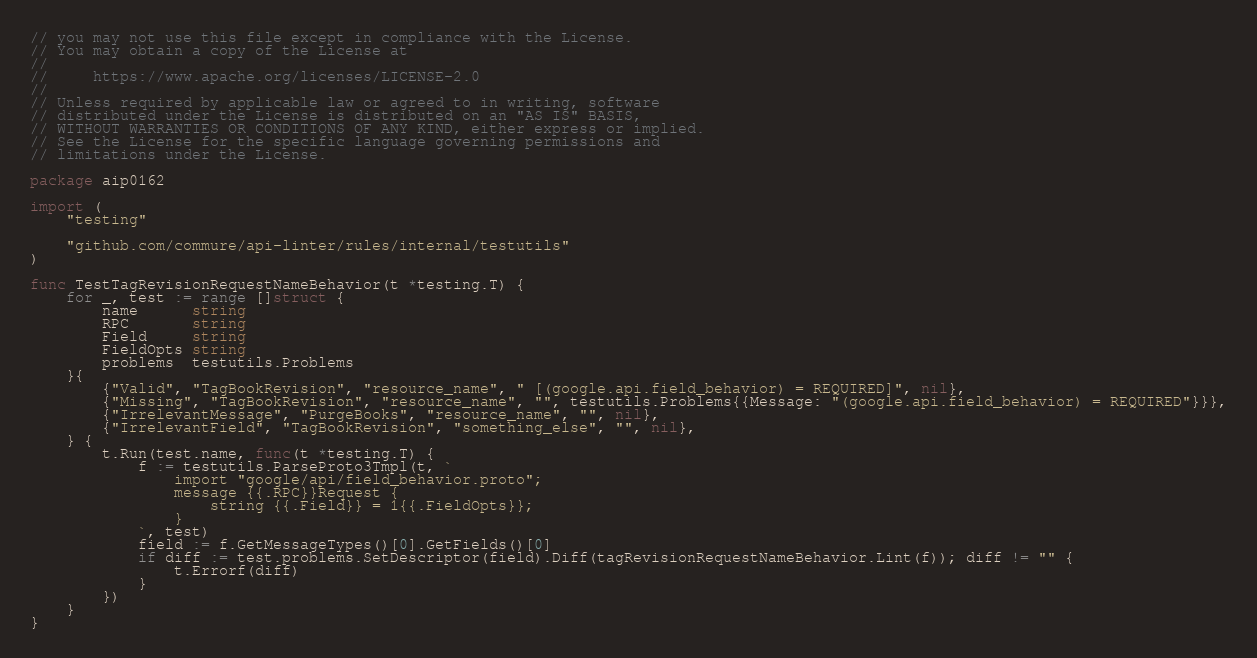<code> <loc_0><loc_0><loc_500><loc_500><_Go_>// you may not use this file except in compliance with the License.
// You may obtain a copy of the License at
//
//     https://www.apache.org/licenses/LICENSE-2.0
//
// Unless required by applicable law or agreed to in writing, software
// distributed under the License is distributed on an "AS IS" BASIS,
// WITHOUT WARRANTIES OR CONDITIONS OF ANY KIND, either express or implied.
// See the License for the specific language governing permissions and
// limitations under the License.

package aip0162

import (
	"testing"

	"github.com/commure/api-linter/rules/internal/testutils"
)

func TestTagRevisionRequestNameBehavior(t *testing.T) {
	for _, test := range []struct {
		name      string
		RPC       string
		Field     string
		FieldOpts string
		problems  testutils.Problems
	}{
		{"Valid", "TagBookRevision", "resource_name", " [(google.api.field_behavior) = REQUIRED]", nil},
		{"Missing", "TagBookRevision", "resource_name", "", testutils.Problems{{Message: "(google.api.field_behavior) = REQUIRED"}}},
		{"IrrelevantMessage", "PurgeBooks", "resource_name", "", nil},
		{"IrrelevantField", "TagBookRevision", "something_else", "", nil},
	} {
		t.Run(test.name, func(t *testing.T) {
			f := testutils.ParseProto3Tmpl(t, `
				import "google/api/field_behavior.proto";
				message {{.RPC}}Request {
					string {{.Field}} = 1{{.FieldOpts}};
				}
			`, test)
			field := f.GetMessageTypes()[0].GetFields()[0]
			if diff := test.problems.SetDescriptor(field).Diff(tagRevisionRequestNameBehavior.Lint(f)); diff != "" {
				t.Errorf(diff)
			}
		})
	}
}
</code> 